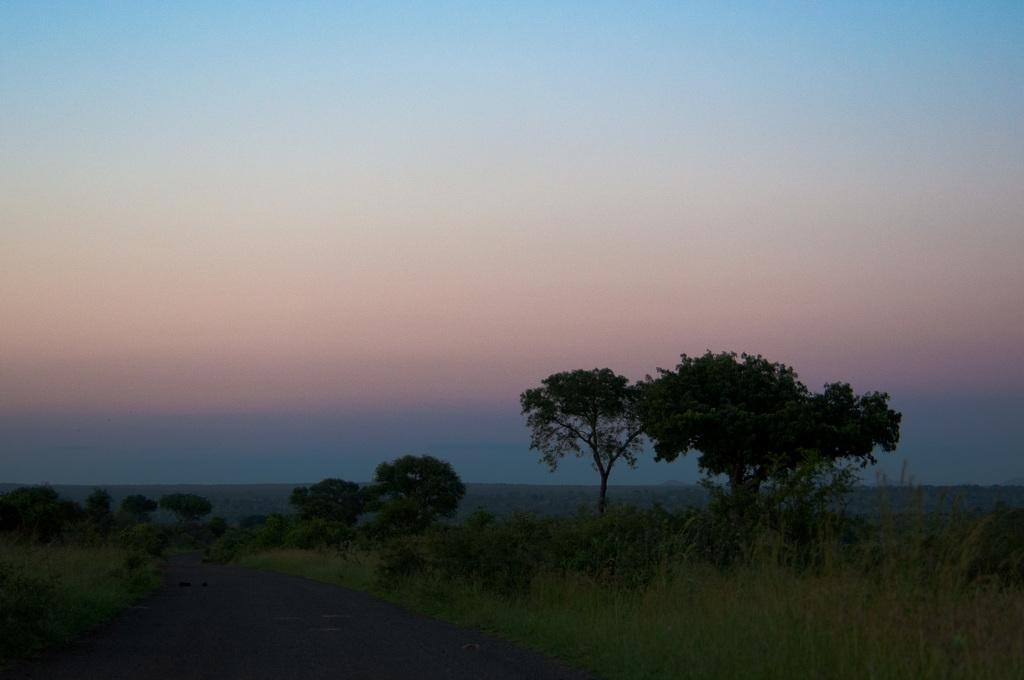What is the main feature in the middle of the image? There is a road in the middle of the image. What can be seen on both sides of the road? There are trees on either side of the road. What is visible at the top of the image? The sky is visible at the top of the image. What type of vegetation is present beside the road? There is grass and small plants beside the road. What type of bun is being served in the alley at night in the image? There is no bun, alley, or nighttime scene present in the image. 